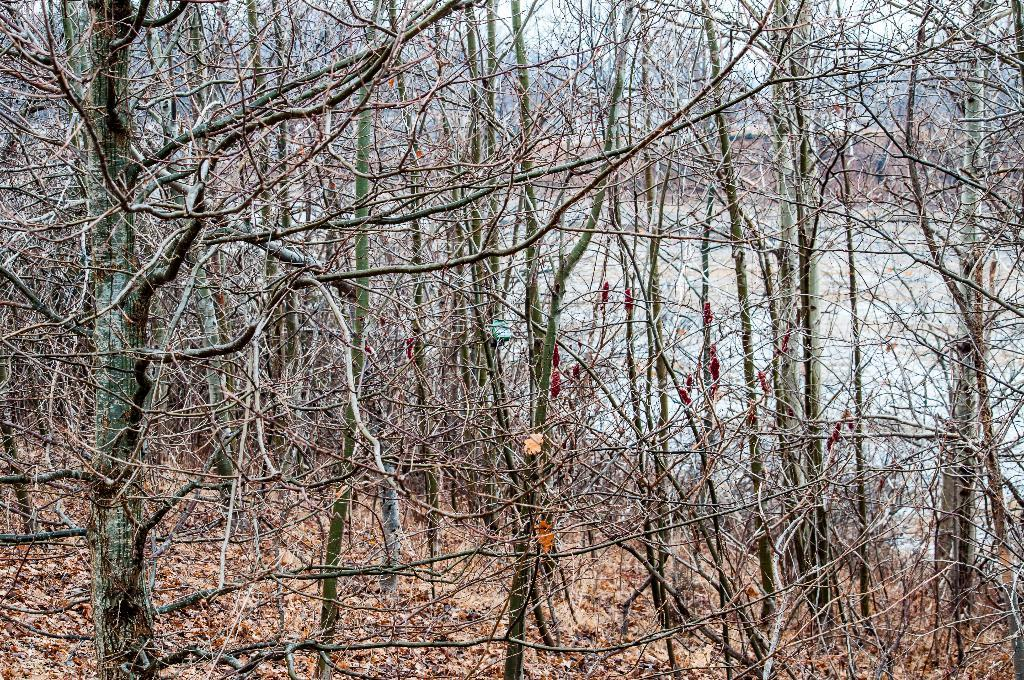What type of vegetation can be seen in the image? There are trees in the image. What is present at the bottom of the image? Dry leaves and twigs are visible at the bottom of the image. Can you describe the background of the image? There are trees in the background of the image. How many dimes can be seen on the branches of the trees in the image? There are no dimes present on the branches of the trees in the image. 